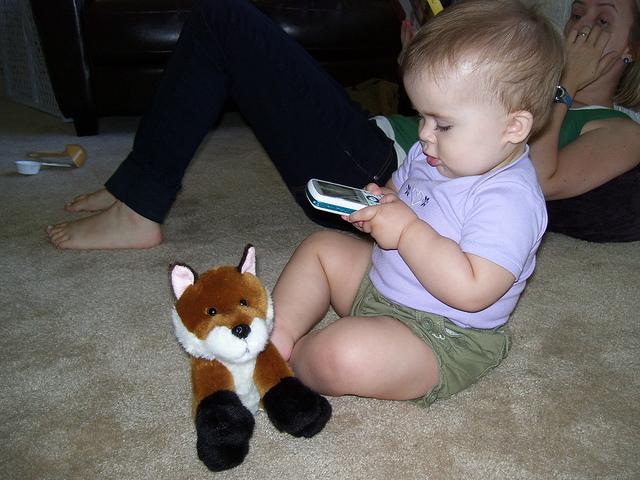What is the woman in the background doing?
Be succinct. Laying down. What type of animal is that?
Give a very brief answer. Fox. Is the child playing?
Quick response, please. Yes. 